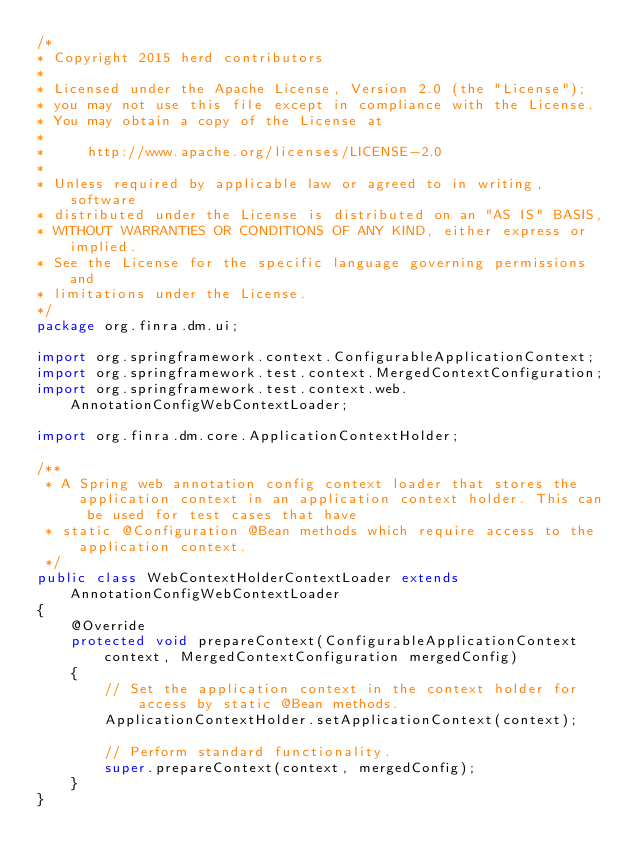Convert code to text. <code><loc_0><loc_0><loc_500><loc_500><_Java_>/*
* Copyright 2015 herd contributors
*
* Licensed under the Apache License, Version 2.0 (the "License");
* you may not use this file except in compliance with the License.
* You may obtain a copy of the License at
*
*     http://www.apache.org/licenses/LICENSE-2.0
*
* Unless required by applicable law or agreed to in writing, software
* distributed under the License is distributed on an "AS IS" BASIS,
* WITHOUT WARRANTIES OR CONDITIONS OF ANY KIND, either express or implied.
* See the License for the specific language governing permissions and
* limitations under the License.
*/
package org.finra.dm.ui;

import org.springframework.context.ConfigurableApplicationContext;
import org.springframework.test.context.MergedContextConfiguration;
import org.springframework.test.context.web.AnnotationConfigWebContextLoader;

import org.finra.dm.core.ApplicationContextHolder;

/**
 * A Spring web annotation config context loader that stores the application context in an application context holder. This can be used for test cases that have
 * static @Configuration @Bean methods which require access to the application context.
 */
public class WebContextHolderContextLoader extends AnnotationConfigWebContextLoader
{
    @Override
    protected void prepareContext(ConfigurableApplicationContext context, MergedContextConfiguration mergedConfig)
    {
        // Set the application context in the context holder for access by static @Bean methods.
        ApplicationContextHolder.setApplicationContext(context);

        // Perform standard functionality.
        super.prepareContext(context, mergedConfig);
    }
}
</code> 